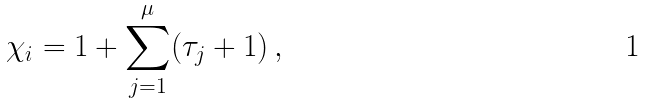<formula> <loc_0><loc_0><loc_500><loc_500>\chi _ { i } = 1 + \sum _ { j = 1 } ^ { \mu } ( \tau _ { j } + 1 ) \, ,</formula> 